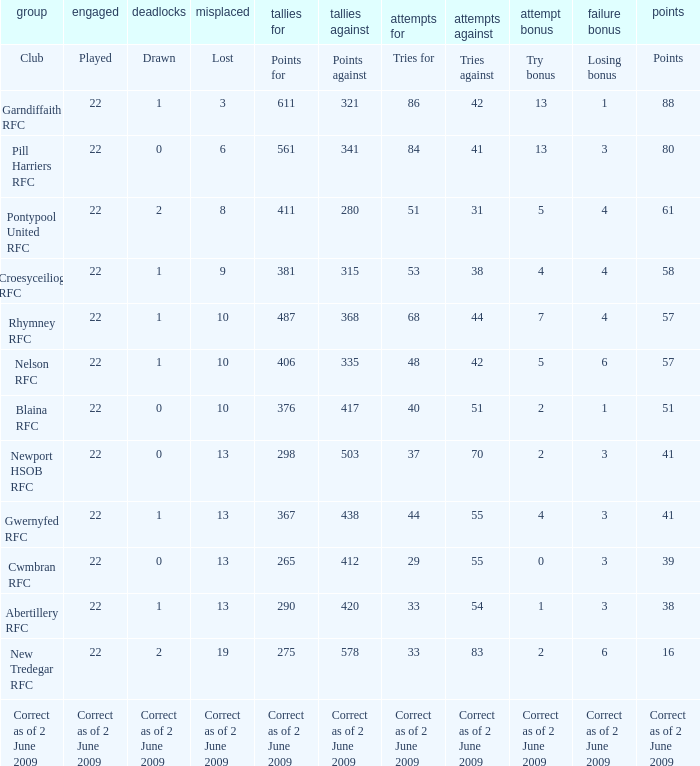How many tries did the club Croesyceiliog rfc have? 53.0. 